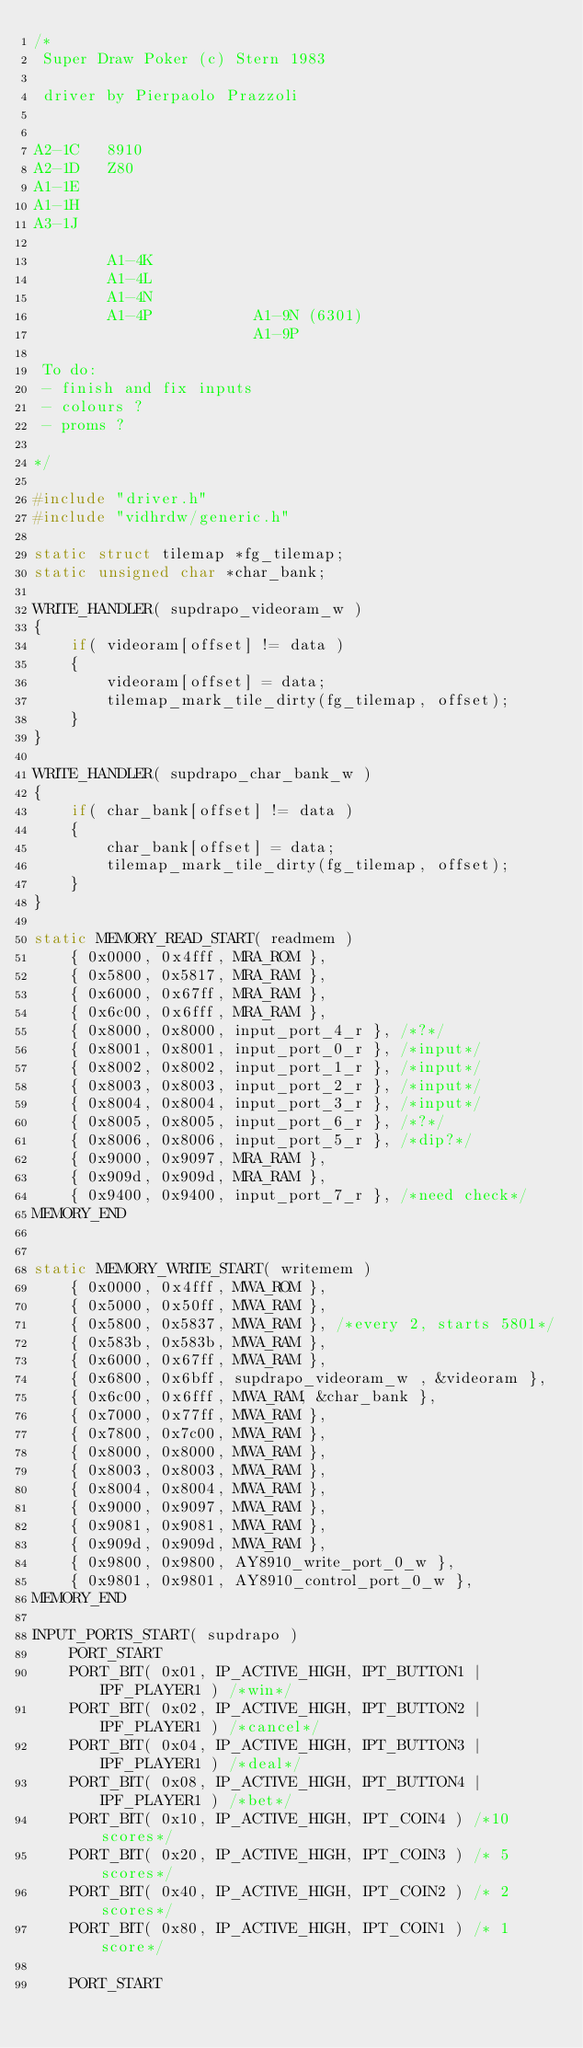Convert code to text. <code><loc_0><loc_0><loc_500><loc_500><_C_>/*
 Super Draw Poker (c) Stern 1983

 driver by Pierpaolo Prazzoli


A2-1C   8910
A2-1D   Z80
A1-1E
A1-1H
A3-1J

        A1-4K
        A1-4L
        A1-4N
        A1-4P           A1-9N (6301)
                        A1-9P

 To do:
 - finish and fix inputs
 - colours ?
 - proms ?

*/

#include "driver.h"
#include "vidhrdw/generic.h"

static struct tilemap *fg_tilemap;
static unsigned char *char_bank;

WRITE_HANDLER( supdrapo_videoram_w )
{
	if( videoram[offset] != data )
	{
		videoram[offset] = data;
		tilemap_mark_tile_dirty(fg_tilemap, offset);
	}
}

WRITE_HANDLER( supdrapo_char_bank_w )
{
	if( char_bank[offset] != data )
	{
		char_bank[offset] = data;
		tilemap_mark_tile_dirty(fg_tilemap, offset);
	}
}

static MEMORY_READ_START( readmem )
	{ 0x0000, 0x4fff, MRA_ROM },
	{ 0x5800, 0x5817, MRA_RAM },
	{ 0x6000, 0x67ff, MRA_RAM },
	{ 0x6c00, 0x6fff, MRA_RAM },
	{ 0x8000, 0x8000, input_port_4_r }, /*?*/
	{ 0x8001, 0x8001, input_port_0_r }, /*input*/
	{ 0x8002, 0x8002, input_port_1_r }, /*input*/
	{ 0x8003, 0x8003, input_port_2_r }, /*input*/
	{ 0x8004, 0x8004, input_port_3_r }, /*input*/
	{ 0x8005, 0x8005, input_port_6_r }, /*?*/
	{ 0x8006, 0x8006, input_port_5_r }, /*dip?*/
	{ 0x9000, 0x9097, MRA_RAM },
	{ 0x909d, 0x909d, MRA_RAM },
	{ 0x9400, 0x9400, input_port_7_r }, /*need check*/
MEMORY_END


static MEMORY_WRITE_START( writemem )
	{ 0x0000, 0x4fff, MWA_ROM },
	{ 0x5000, 0x50ff, MWA_RAM },
	{ 0x5800, 0x5837, MWA_RAM }, /*every 2, starts 5801*/
	{ 0x583b, 0x583b, MWA_RAM },
	{ 0x6000, 0x67ff, MWA_RAM },
	{ 0x6800, 0x6bff, supdrapo_videoram_w , &videoram },
	{ 0x6c00, 0x6fff, MWA_RAM, &char_bank },
	{ 0x7000, 0x77ff, MWA_RAM },
	{ 0x7800, 0x7c00, MWA_RAM },
	{ 0x8000, 0x8000, MWA_RAM },
	{ 0x8003, 0x8003, MWA_RAM },
	{ 0x8004, 0x8004, MWA_RAM },
	{ 0x9000, 0x9097, MWA_RAM },
	{ 0x9081, 0x9081, MWA_RAM },
	{ 0x909d, 0x909d, MWA_RAM },
	{ 0x9800, 0x9800, AY8910_write_port_0_w },
	{ 0x9801, 0x9801, AY8910_control_port_0_w },
MEMORY_END

INPUT_PORTS_START( supdrapo )
	PORT_START
	PORT_BIT( 0x01, IP_ACTIVE_HIGH, IPT_BUTTON1 | IPF_PLAYER1 ) /*win*/
	PORT_BIT( 0x02, IP_ACTIVE_HIGH, IPT_BUTTON2 | IPF_PLAYER1 ) /*cancel*/
	PORT_BIT( 0x04, IP_ACTIVE_HIGH, IPT_BUTTON3 | IPF_PLAYER1 ) /*deal*/
	PORT_BIT( 0x08, IP_ACTIVE_HIGH, IPT_BUTTON4 | IPF_PLAYER1 ) /*bet*/
	PORT_BIT( 0x10, IP_ACTIVE_HIGH, IPT_COIN4 ) /*10 scores*/
	PORT_BIT( 0x20, IP_ACTIVE_HIGH, IPT_COIN3 ) /* 5 scores*/
	PORT_BIT( 0x40, IP_ACTIVE_HIGH, IPT_COIN2 ) /* 2 scores*/
	PORT_BIT( 0x80, IP_ACTIVE_HIGH, IPT_COIN1 ) /* 1 score*/

	PORT_START</code> 